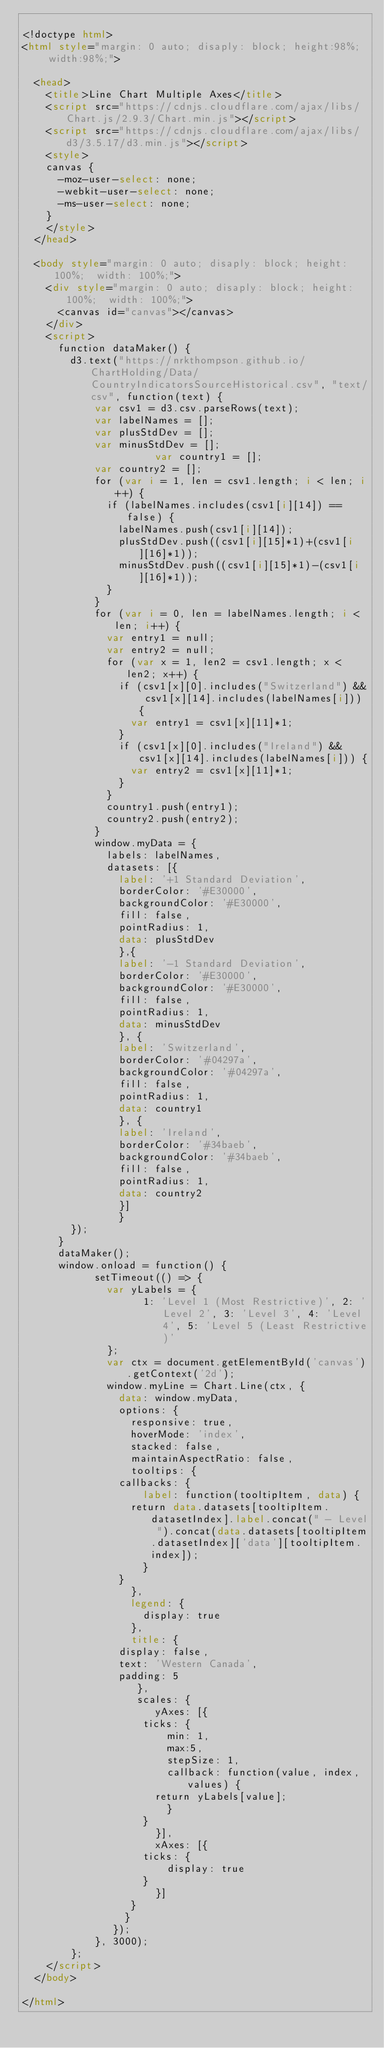<code> <loc_0><loc_0><loc_500><loc_500><_HTML_>
<!doctype html>
<html style="margin: 0 auto; disaply: block; height:98%;  width:98%;">

	<head>
		<title>Line Chart Multiple Axes</title>
		<script src="https://cdnjs.cloudflare.com/ajax/libs/Chart.js/2.9.3/Chart.min.js"></script>
		<script src="https://cdnjs.cloudflare.com/ajax/libs/d3/3.5.17/d3.min.js"></script>
		<style>
		canvas {
			-moz-user-select: none;
			-webkit-user-select: none;
			-ms-user-select: none;
		}
		</style>
	</head>

	<body style="margin: 0 auto; disaply: block; height: 100%;  width: 100%;">
		<div style="margin: 0 auto; disaply: block; height: 100%;  width: 100%;">
			<canvas id="canvas"></canvas>
		</div>
		<script>
			function dataMaker() {
				d3.text("https://nrkthompson.github.io/ChartHolding/Data/CountryIndicatorsSourceHistorical.csv", "text/csv", function(text) {
					  var csv1 = d3.csv.parseRows(text);
					  var labelNames = [];
					  var plusStdDev = [];
					  var minusStdDev = [];
            				  var country1 = [];
					  var country2 = [];
					  for (var i = 1, len = csv1.length; i < len; i++) {
						  if (labelNames.includes(csv1[i][14]) == false) {
							  labelNames.push(csv1[i][14]);
							  plusStdDev.push((csv1[i][15]*1)+(csv1[i][16]*1));
							  minusStdDev.push((csv1[i][15]*1)-(csv1[i][16]*1));
						  }
					  }
					  for (var i = 0, len = labelNames.length; i < len; i++) {
						  var entry1 = null;
						  var entry2 = null;
						  for (var x = 1, len2 = csv1.length; x < len2; x++) {
							  if (csv1[x][0].includes("Switzerland") && csv1[x][14].includes(labelNames[i])) {
								  var entry1 = csv1[x][11]*1;
							  }
							  if (csv1[x][0].includes("Ireland") && csv1[x][14].includes(labelNames[i])) {
								  var entry2 = csv1[x][11]*1;
							  }
						  }
						  country1.push(entry1);
						  country2.push(entry2);
					  }
					  window.myData = {
						  labels: labelNames,
						  datasets: [{
						    label: '+1 Standard Deviation',
						    borderColor: '#E30000',
						    backgroundColor: '#E30000',
						    fill: false,
						    pointRadius: 1,
						    data: plusStdDev
						    },{
						    label: '-1 Standard Deviation',
						    borderColor: '#E30000',
						    backgroundColor: '#E30000',
						    fill: false,
						    pointRadius: 1,
						    data: minusStdDev
						    }, {
						    label: 'Switzerland',
						    borderColor: '#04297a',
						    backgroundColor: '#04297a',
						    fill: false,
						    pointRadius: 1,
						    data: country1
						    }, {
						    label: 'Ireland',
						    borderColor: '#34baeb',
						    backgroundColor: '#34baeb',
						    fill: false,
						    pointRadius: 1,
						    data: country2
						    }]
						    }  
				});
			}
			dataMaker();
			window.onload = function() {
						setTimeout(() => { 
							var yLabels = {
							      1: 'Level 1 (Most Restrictive)', 2: 'Level 2', 3: 'Level 3', 4: 'Level 4', 5: 'Level 5 (Least Restrictive)'
							};
							var ctx = document.getElementById('canvas').getContext('2d');
							window.myLine = Chart.Line(ctx, {
							  data: window.myData,
							  options: {
							    responsive: true,
							    hoverMode: 'index',
							    stacked: false,
							    maintainAspectRatio: false,
							    tooltips: {
								callbacks: {
								    label: function(tooltipItem, data) {
									return data.datasets[tooltipItem.datasetIndex].label.concat(" - Level ").concat(data.datasets[tooltipItem.datasetIndex]['data'][tooltipItem.index]);
								    }
								}
							    },
							    legend: {
								    display: true
							    },
							    title: {
								display: false,
								text: 'Western Canada',
								padding: 5
							     },
							     scales: {
								      yAxes: [{
									  ticks: {
									      min: 1,
									      max:5,
									      stepSize: 1,
									      callback: function(value, index, values) {
										  return yLabels[value];
									      }
									  }
								      }],
								      xAxes: [{
									  ticks: {
									      display: true
									  }
								      }]
								  }
							   }
							 });
						}, 3000);
				};
		</script>
	</body>

</html></code> 